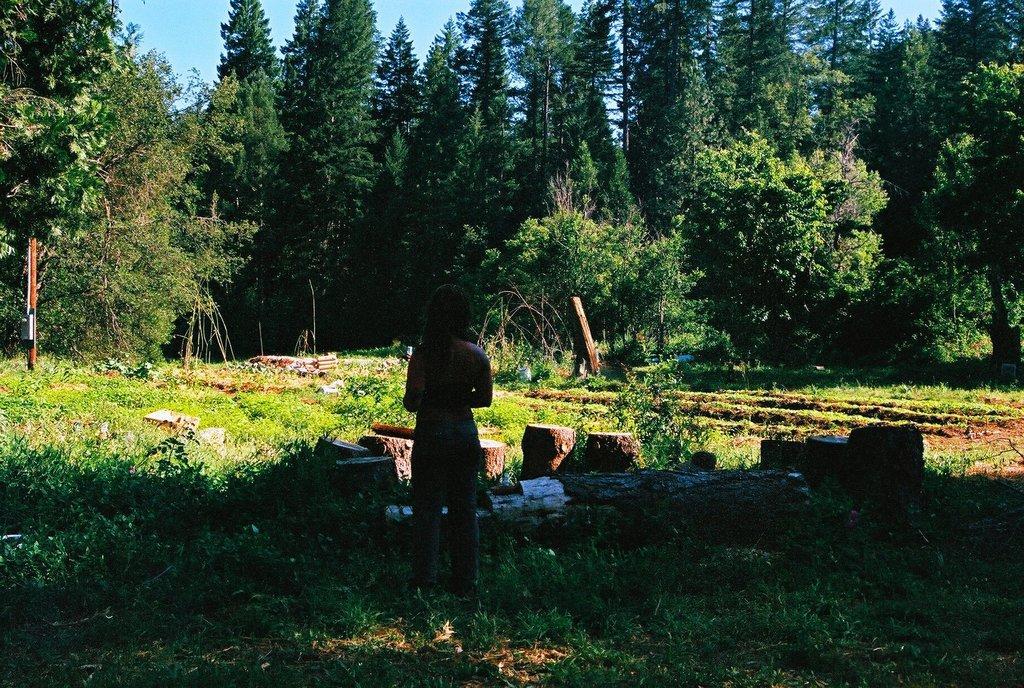How would you summarize this image in a sentence or two? In this image I can see the person standing on the grass. In-front of the person I can see the tree trunks. In the background I can see many trees and the blue sky. 